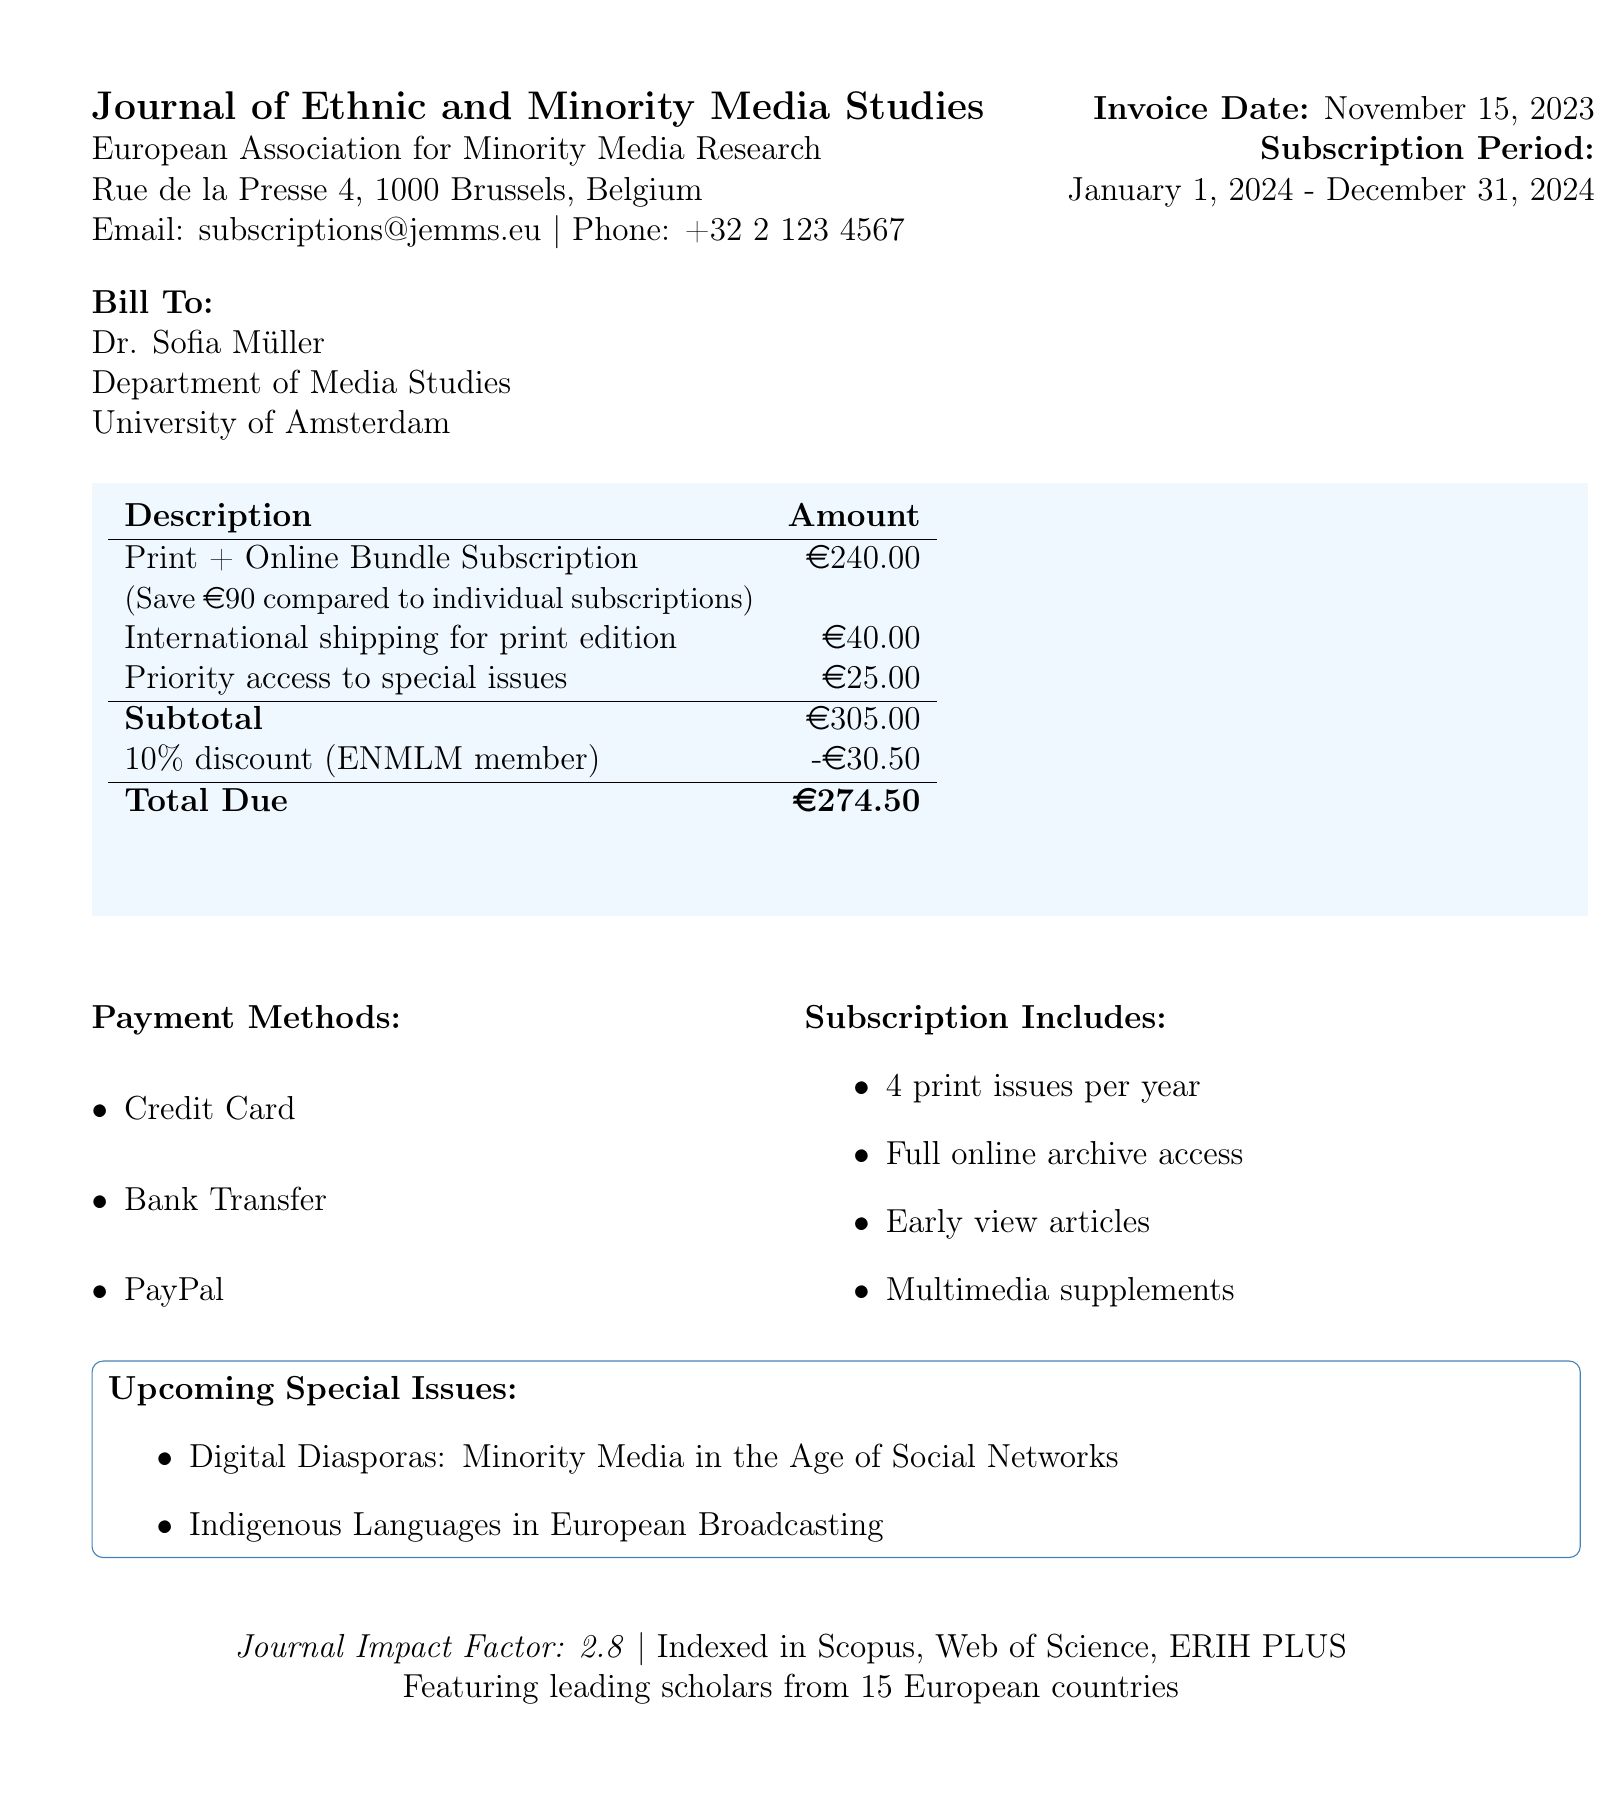What is the journal name? The journal name is provided at the top of the document.
Answer: Journal of Ethnic and Minority Media Studies Who is the subscriber? The subscriber's name is listed under "Bill To".
Answer: Dr. Sofia Müller What is the invoice number? The invoice number is featured prominently at the top of the document.
Answer: JEMMS-2024-1853 What is the total due amount? The total due amount is calculated based on the subtotal and discounts in the invoice section.
Answer: €274.50 How many issues are included in the print subscription? The number of issues per year for the print subscription is specified in the subscription options.
Answer: 4 What discount is available for members of the European Network for Minority Language Media? The document mentions a special offer for members of a specific network, which is a percentage discount.
Answer: 10% What is included in the online subscription? The features of the online subscription are listed in the subscription options section.
Answer: Full archive access, Early view articles, Multimedia supplements What is the payment method? Payment methods are listed towards the end of the document.
Answer: Credit Card, Bank Transfer, PayPal What is the impact factor of the journal? The impact factor is stated in the bottom section of the document.
Answer: 2.8 